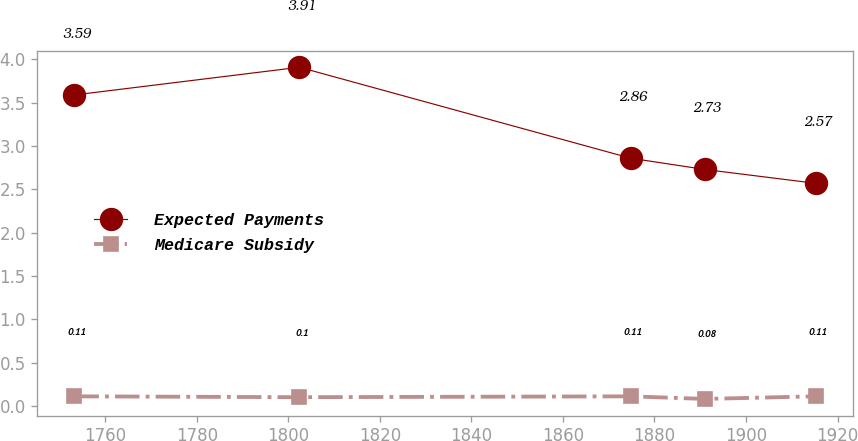Convert chart to OTSL. <chart><loc_0><loc_0><loc_500><loc_500><line_chart><ecel><fcel>Expected Payments<fcel>Medicare Subsidy<nl><fcel>1753.22<fcel>3.59<fcel>0.11<nl><fcel>1802.4<fcel>3.91<fcel>0.1<nl><fcel>1874.77<fcel>2.86<fcel>0.11<nl><fcel>1890.97<fcel>2.73<fcel>0.08<nl><fcel>1915.2<fcel>2.57<fcel>0.11<nl></chart> 